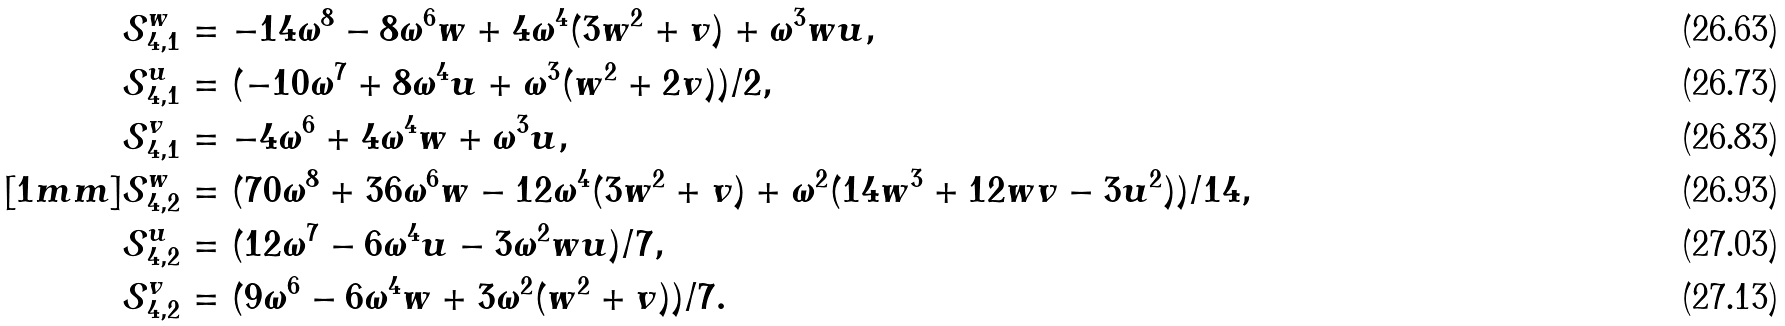<formula> <loc_0><loc_0><loc_500><loc_500>\mathcal { S } _ { 4 , 1 } ^ { w } & = - 1 4 \omega ^ { 8 } - 8 \omega ^ { 6 } w + 4 \omega ^ { 4 } ( 3 w ^ { 2 } + v ) + \omega ^ { 3 } w u , \\ \mathcal { S } _ { 4 , 1 } ^ { u } & = ( - 1 0 \omega ^ { 7 } + 8 \omega ^ { 4 } u + \omega ^ { 3 } ( w ^ { 2 } + 2 v ) ) / 2 , \\ \mathcal { S } _ { 4 , 1 } ^ { v } & = - 4 \omega ^ { 6 } + 4 \omega ^ { 4 } w + \omega ^ { 3 } u , \\ [ 1 m m ] \mathcal { S } _ { 4 , 2 } ^ { w } & = ( 7 0 \omega ^ { 8 } + 3 6 \omega ^ { 6 } w - 1 2 \omega ^ { 4 } ( 3 w ^ { 2 } + v ) + \omega ^ { 2 } ( 1 4 w ^ { 3 } + 1 2 w v - 3 u ^ { 2 } ) ) / 1 4 , \\ \mathcal { S } _ { 4 , 2 } ^ { u } & = ( 1 2 \omega ^ { 7 } - 6 \omega ^ { 4 } u - 3 \omega ^ { 2 } w u ) / 7 , \\ \mathcal { S } _ { 4 , 2 } ^ { v } & = ( 9 \omega ^ { 6 } - 6 \omega ^ { 4 } w + 3 \omega ^ { 2 } ( w ^ { 2 } + v ) ) / 7 .</formula> 